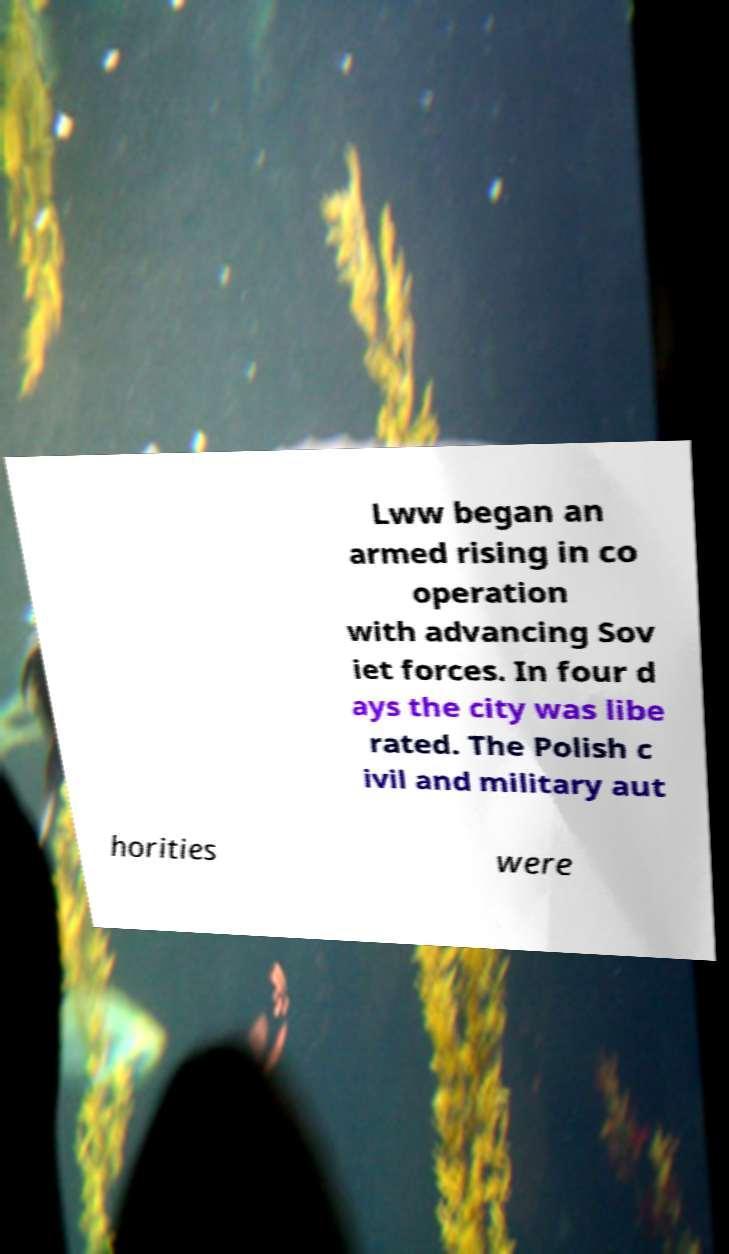Could you extract and type out the text from this image? Lww began an armed rising in co operation with advancing Sov iet forces. In four d ays the city was libe rated. The Polish c ivil and military aut horities were 